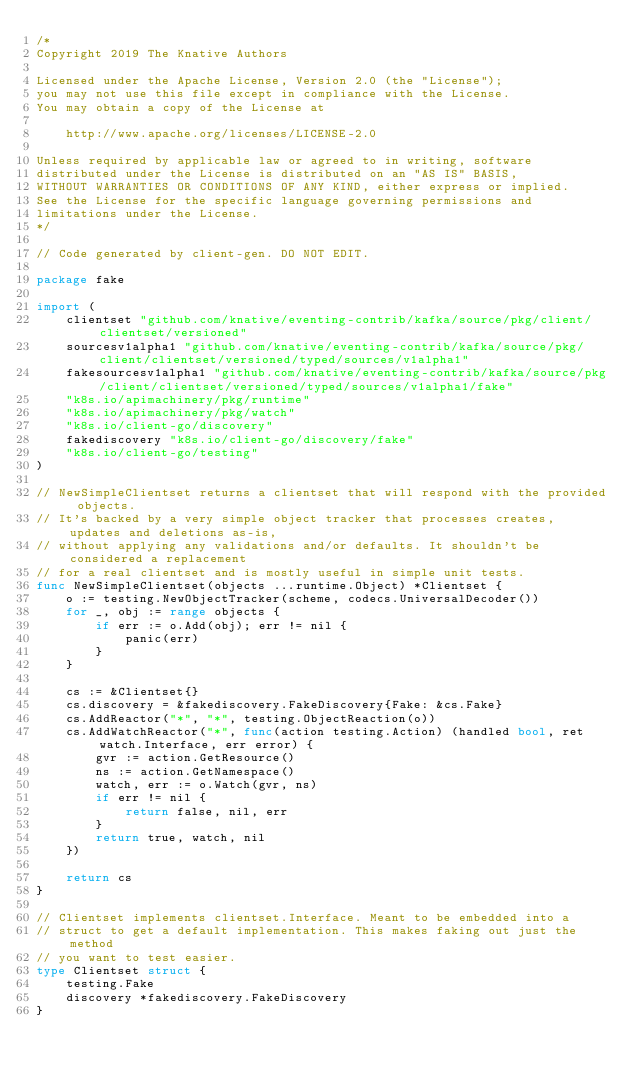<code> <loc_0><loc_0><loc_500><loc_500><_Go_>/*
Copyright 2019 The Knative Authors

Licensed under the Apache License, Version 2.0 (the "License");
you may not use this file except in compliance with the License.
You may obtain a copy of the License at

    http://www.apache.org/licenses/LICENSE-2.0

Unless required by applicable law or agreed to in writing, software
distributed under the License is distributed on an "AS IS" BASIS,
WITHOUT WARRANTIES OR CONDITIONS OF ANY KIND, either express or implied.
See the License for the specific language governing permissions and
limitations under the License.
*/

// Code generated by client-gen. DO NOT EDIT.

package fake

import (
	clientset "github.com/knative/eventing-contrib/kafka/source/pkg/client/clientset/versioned"
	sourcesv1alpha1 "github.com/knative/eventing-contrib/kafka/source/pkg/client/clientset/versioned/typed/sources/v1alpha1"
	fakesourcesv1alpha1 "github.com/knative/eventing-contrib/kafka/source/pkg/client/clientset/versioned/typed/sources/v1alpha1/fake"
	"k8s.io/apimachinery/pkg/runtime"
	"k8s.io/apimachinery/pkg/watch"
	"k8s.io/client-go/discovery"
	fakediscovery "k8s.io/client-go/discovery/fake"
	"k8s.io/client-go/testing"
)

// NewSimpleClientset returns a clientset that will respond with the provided objects.
// It's backed by a very simple object tracker that processes creates, updates and deletions as-is,
// without applying any validations and/or defaults. It shouldn't be considered a replacement
// for a real clientset and is mostly useful in simple unit tests.
func NewSimpleClientset(objects ...runtime.Object) *Clientset {
	o := testing.NewObjectTracker(scheme, codecs.UniversalDecoder())
	for _, obj := range objects {
		if err := o.Add(obj); err != nil {
			panic(err)
		}
	}

	cs := &Clientset{}
	cs.discovery = &fakediscovery.FakeDiscovery{Fake: &cs.Fake}
	cs.AddReactor("*", "*", testing.ObjectReaction(o))
	cs.AddWatchReactor("*", func(action testing.Action) (handled bool, ret watch.Interface, err error) {
		gvr := action.GetResource()
		ns := action.GetNamespace()
		watch, err := o.Watch(gvr, ns)
		if err != nil {
			return false, nil, err
		}
		return true, watch, nil
	})

	return cs
}

// Clientset implements clientset.Interface. Meant to be embedded into a
// struct to get a default implementation. This makes faking out just the method
// you want to test easier.
type Clientset struct {
	testing.Fake
	discovery *fakediscovery.FakeDiscovery
}
</code> 